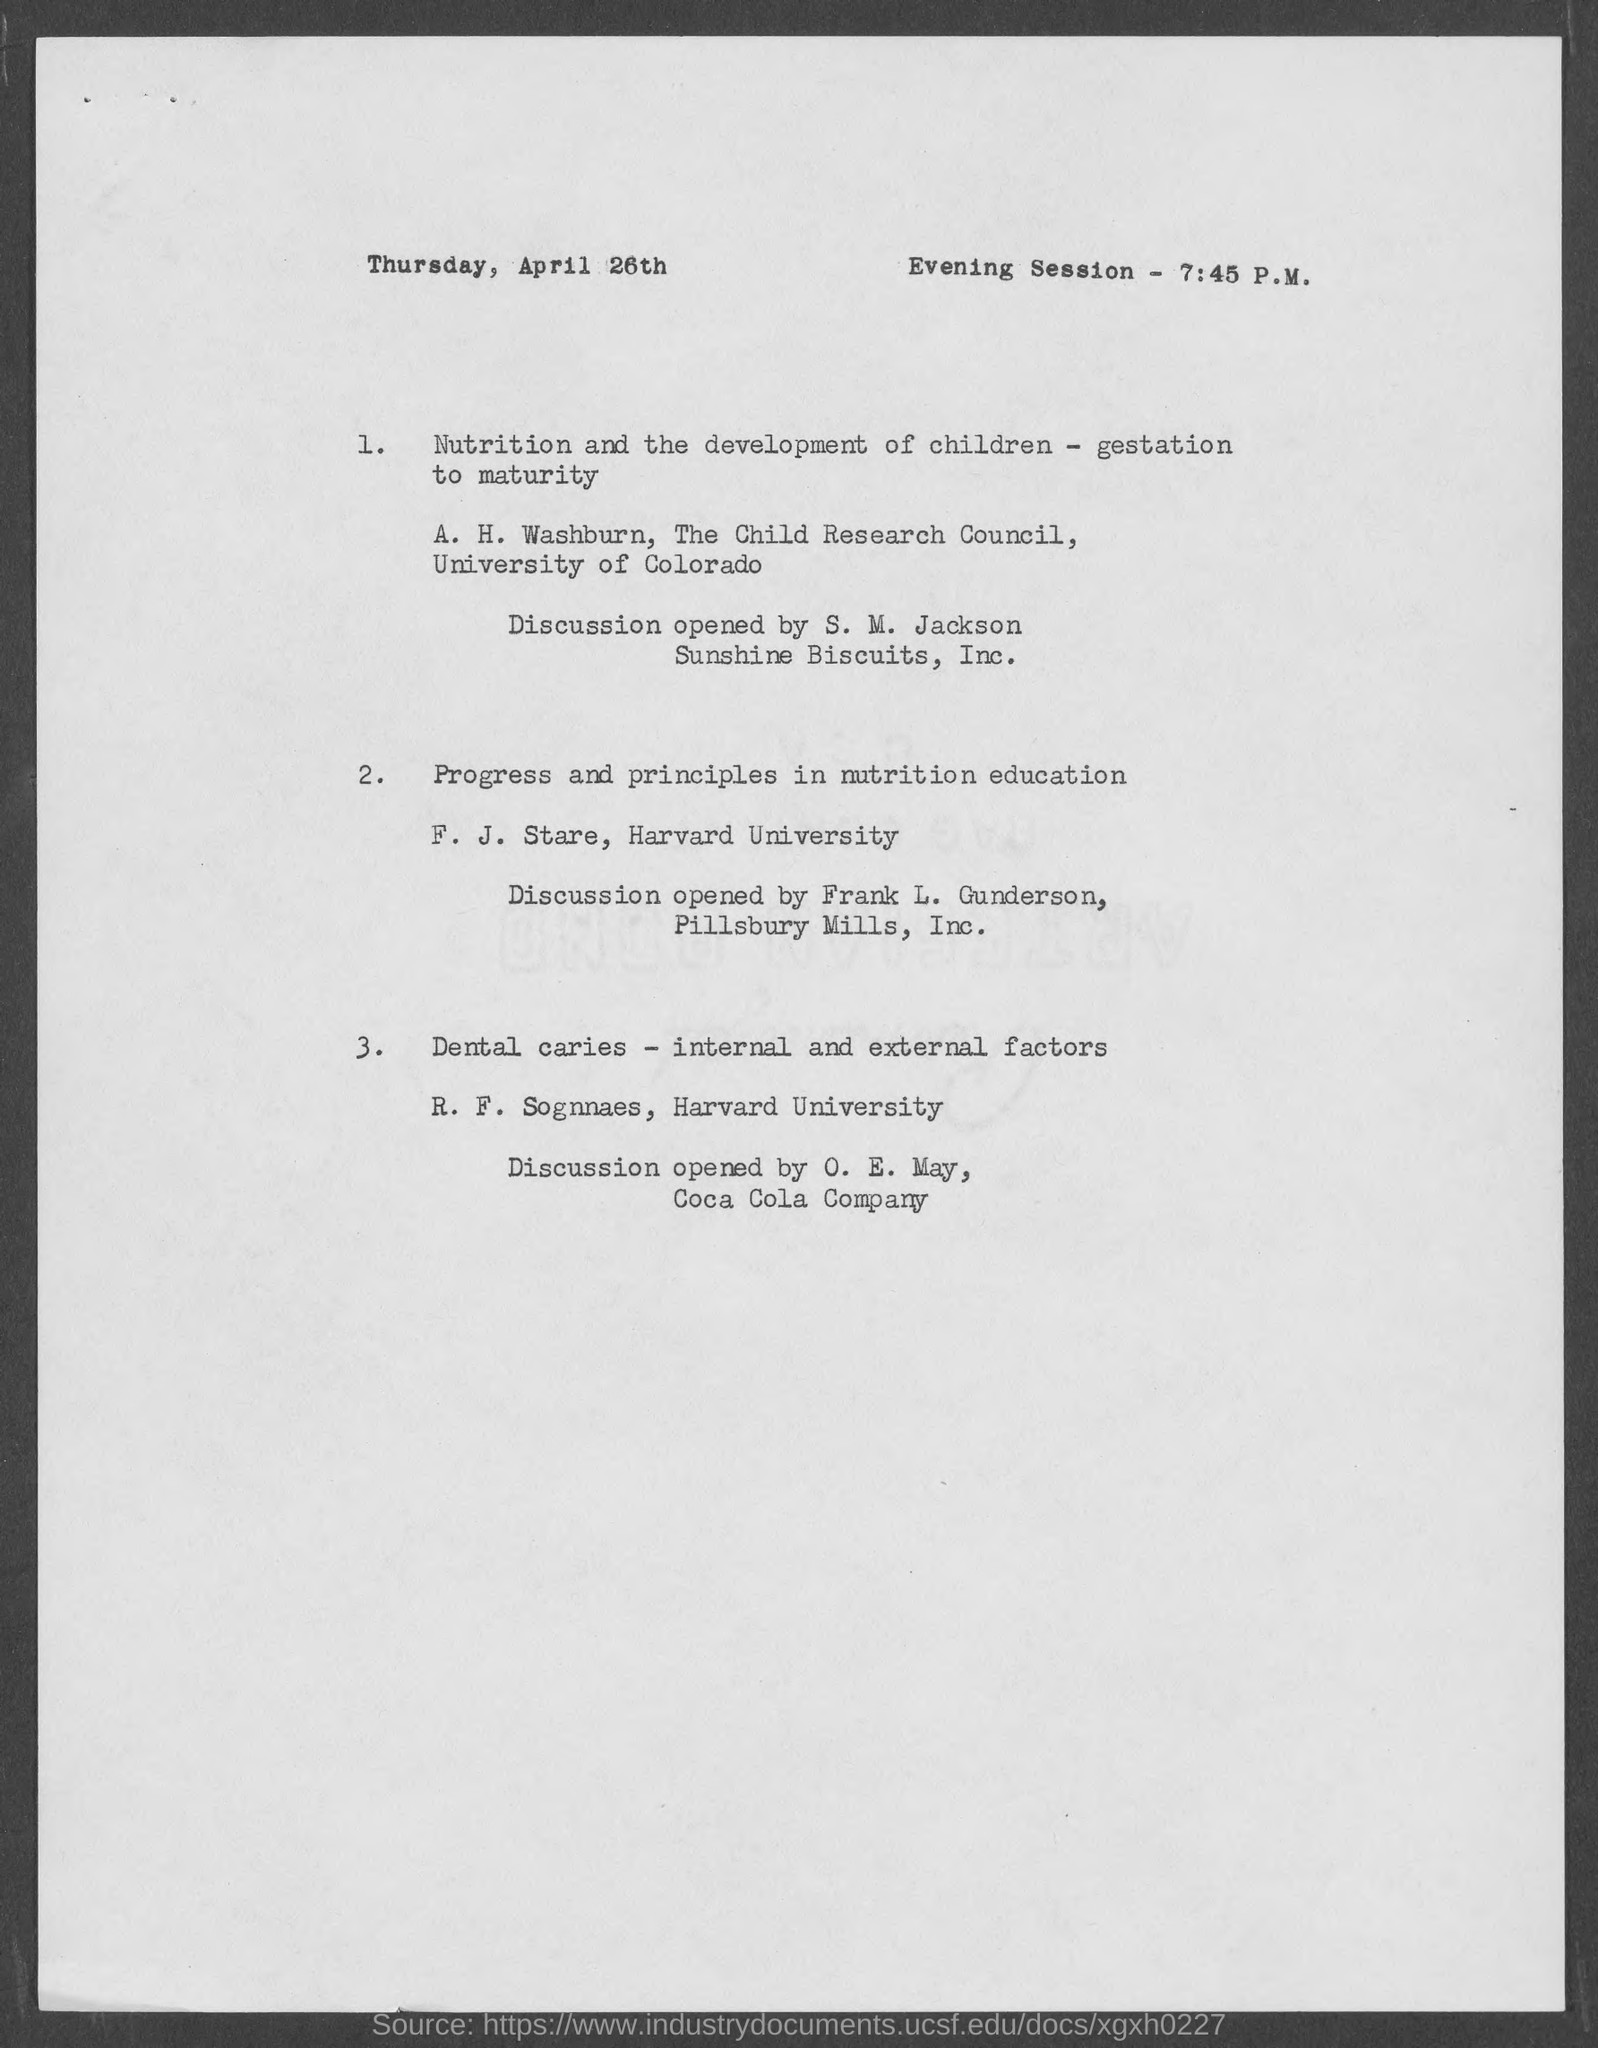List a handful of essential elements in this visual. O. E. May works for the Coca-Cola Company. The document indicates that the date, day, and month are Thursday, April 26th. The evening session will commence at 7:45 P.M. The person who led the discussion of the paper titled "Progress and Principles in Nutrition Education" was F. J. Stare. The discussion of the paper "Nutrition and the Development of Children - Gestation to Maturity" was conducted by A. H. Washburn. 